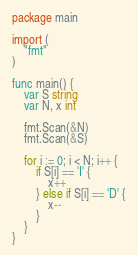<code> <loc_0><loc_0><loc_500><loc_500><_Go_>package main

import (
	"fmt"
)

func main() {
	var S string
	var N, x int

	fmt.Scan(&N)
	fmt.Scan(&S)

	for i := 0; i < N; i++ {
		if S[i] == 'I' {
			x++
		} else if S[i] == 'D' {
			x--
		}
	}
}
</code> 